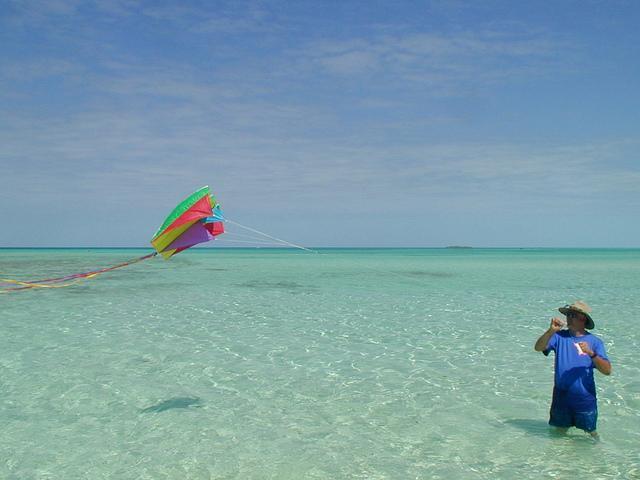How many trains on the track?
Give a very brief answer. 0. 